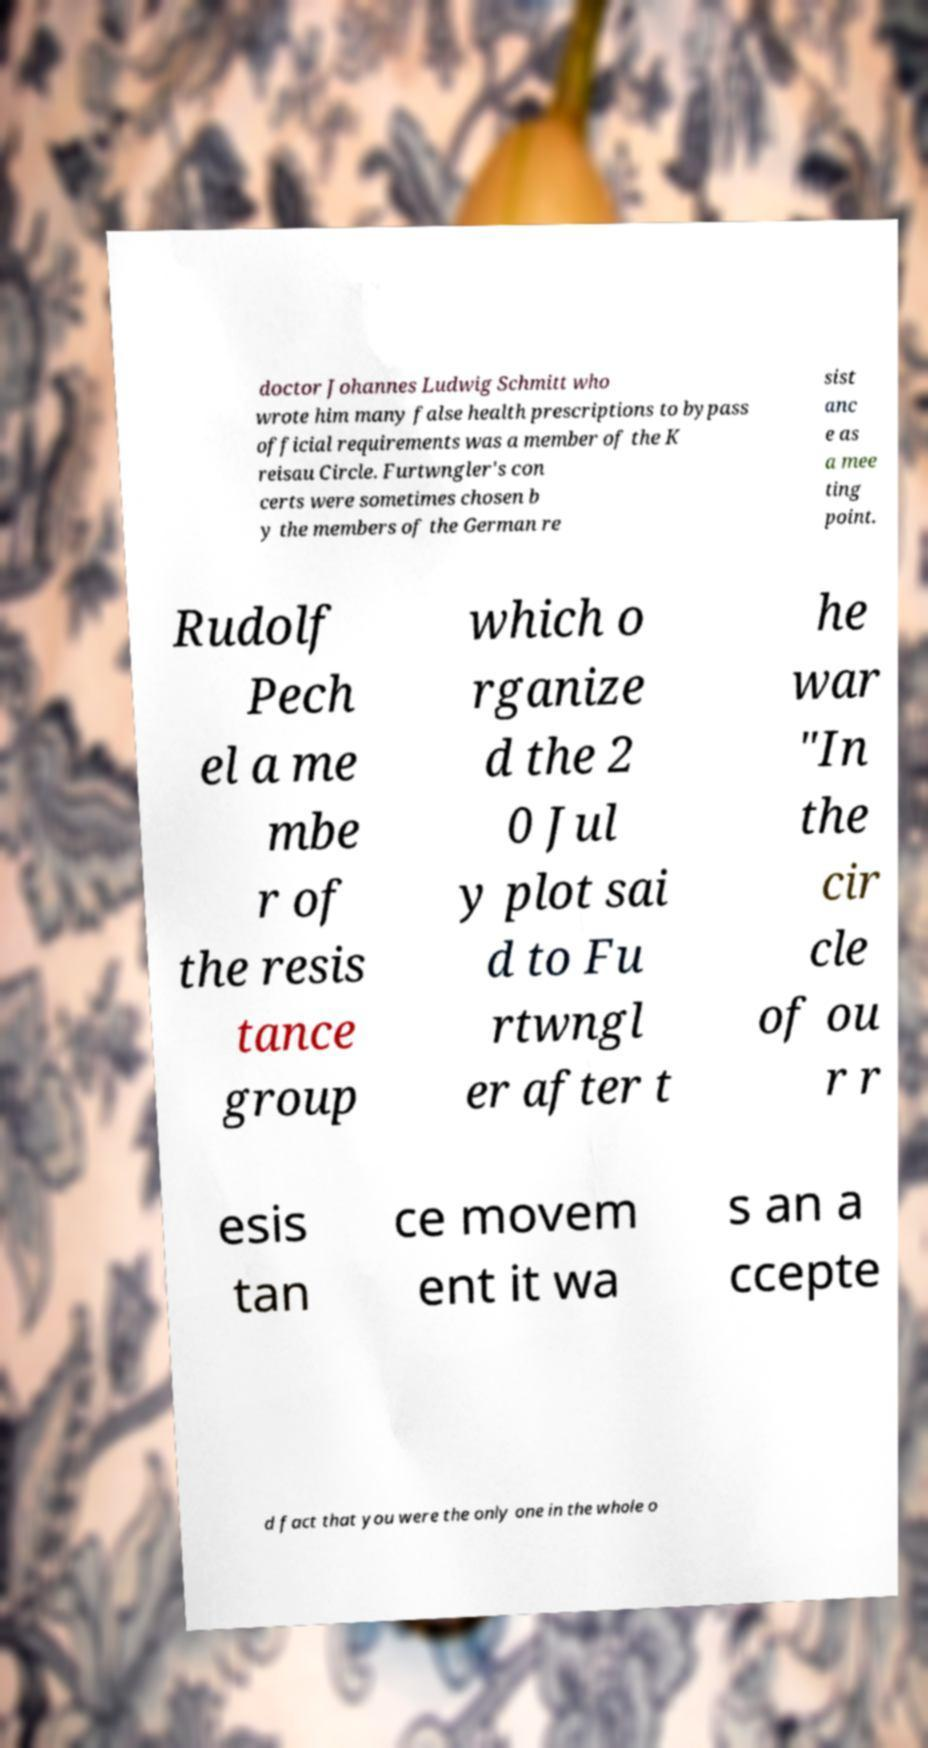Could you assist in decoding the text presented in this image and type it out clearly? doctor Johannes Ludwig Schmitt who wrote him many false health prescriptions to bypass official requirements was a member of the K reisau Circle. Furtwngler's con certs were sometimes chosen b y the members of the German re sist anc e as a mee ting point. Rudolf Pech el a me mbe r of the resis tance group which o rganize d the 2 0 Jul y plot sai d to Fu rtwngl er after t he war "In the cir cle of ou r r esis tan ce movem ent it wa s an a ccepte d fact that you were the only one in the whole o 